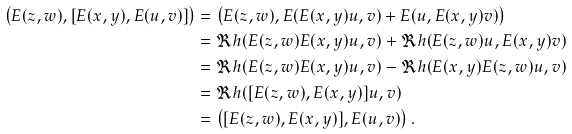<formula> <loc_0><loc_0><loc_500><loc_500>\left ( E ( z , w ) , [ E ( x , y ) , E ( u , v ) ] \right ) & = \left ( E ( z , w ) , E ( E ( x , y ) u , v ) + E ( u , E ( x , y ) v ) \right ) \\ & = \Re h ( E ( z , w ) E ( x , y ) u , v ) + \Re h ( E ( z , w ) u , E ( x , y ) v ) \\ & = \Re h ( E ( z , w ) E ( x , y ) u , v ) - \Re h ( E ( x , y ) E ( z , w ) u , v ) \\ & = \Re h ( [ E ( z , w ) , E ( x , y ) ] u , v ) \\ & = \left ( [ E ( z , w ) , E ( x , y ) ] , E ( u , v ) \right ) .</formula> 